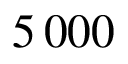<formula> <loc_0><loc_0><loc_500><loc_500>5 \, 0 0 0</formula> 